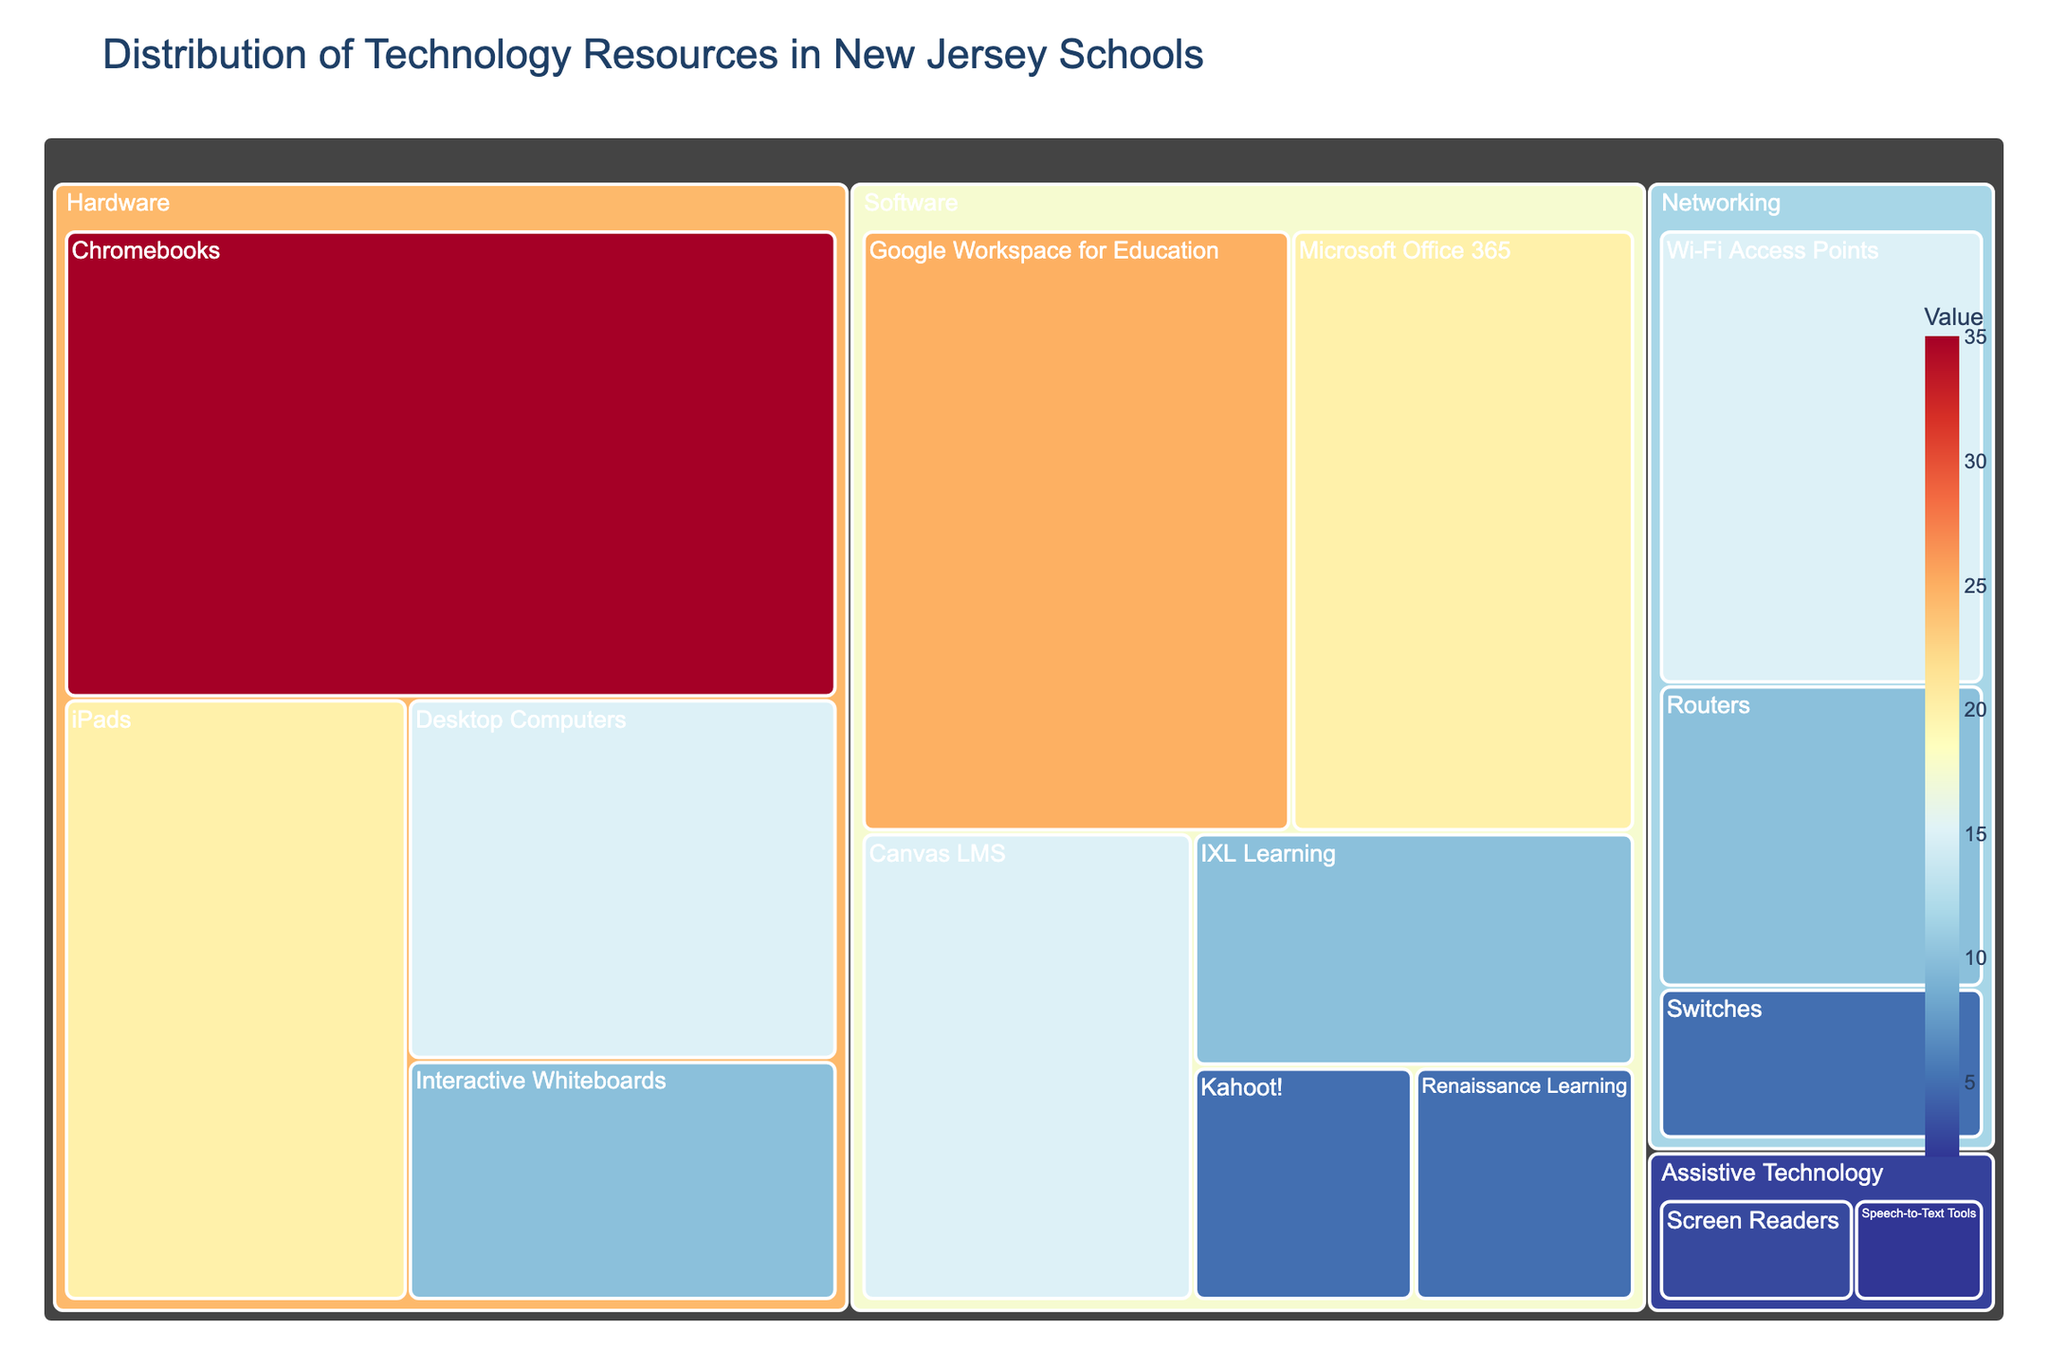What's the title of the figure? The title usually appears at the top of the figure and is written in a larger font size. Here, the title of the treemap is shown at the top of the figure.
Answer: Distribution of Technology Resources in New Jersey Schools Which category has the highest overall value? By observing the largest section of the treemap, we can determine which category occupies the largest area, representing the highest overall value.
Answer: Hardware What is the value of the subcategory 'Chromebooks'? Look at the subcategory labels under the 'Hardware' category and find 'Chromebooks'. The value is displayed either on the block itself or on hover.
Answer: 35 How many different subcategories are listed under 'Software'? Count the number of distinct subcategory blocks under the 'Software' main category in the treemap.
Answer: 6 Which subcategory has the smallest value, and what is that value? Identify the smallest block in the treemap and check its label and value.
Answer: Speech-to-Text Tools, 2 What is the combined value of 'Google Workspace for Education' and 'Microsoft Office 365'? Locate the values for both 'Google Workspace for Education' and 'Microsoft Office 365' under the Software category and add them together: 25 + 20 = 45.
Answer: 45 How does the value of 'Interactive Whiteboards' compare to 'Desktop Computers'? Which is higher? Identify the values for 'Interactive Whiteboards' and 'Desktop Computers' under the Hardware category and compare them: 10 for Interactive Whiteboards vs. 15 for Desktop Computers.
Answer: Desktop Computers What is the total value of all 'Networking' subcategories? Add the values of all subcategories under the 'Networking' category: 15 (Wi-Fi Access Points) + 10 (Routers) + 5 (Switches) = 30.
Answer: 30 What proportion of the total 'Hardware' value is contributed by 'iPads'? Calculate the sum of all 'Hardware' subcategory values, then find the proportion of 'iPads': (20 / (35 + 20 + 15 + 10)) * 100. The total Hardware value is 35 + 20 + 15 + 10 = 80, so the proportion is (20 / 80) * 100 = 25%.
Answer: 25% What is the average value of the 'Assistive Technology' subcategories? Add the values of all subcategories under 'Assistive Technology' and divide by the number of subcategories: (3 + 2) / 2 = 2.5.
Answer: 2.5 